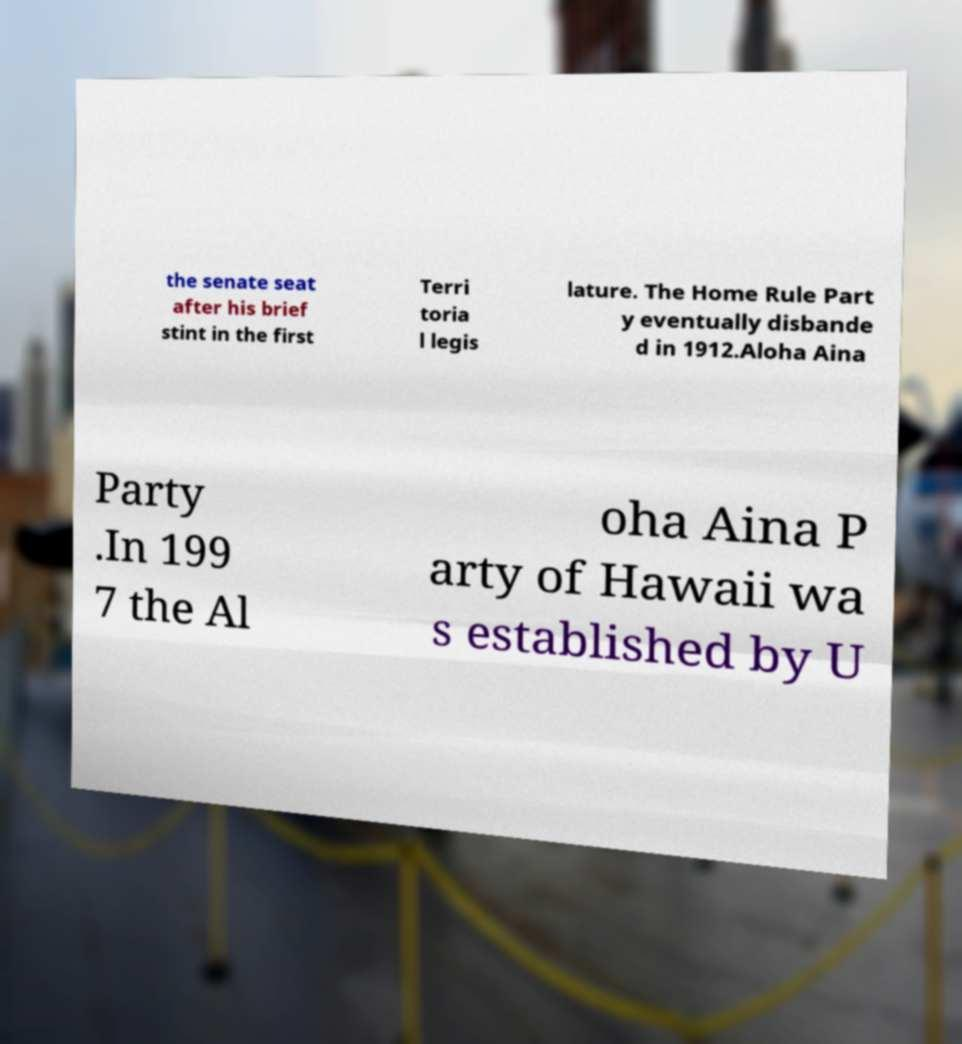Could you extract and type out the text from this image? the senate seat after his brief stint in the first Terri toria l legis lature. The Home Rule Part y eventually disbande d in 1912.Aloha Aina Party .In 199 7 the Al oha Aina P arty of Hawaii wa s established by U 